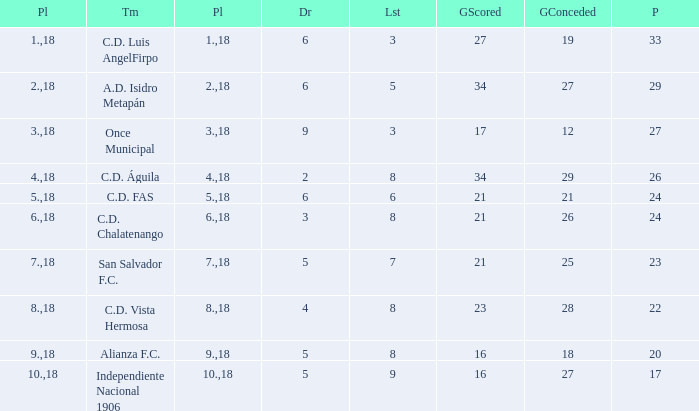What are the number of goals conceded that has a played greater than 18? 0.0. 